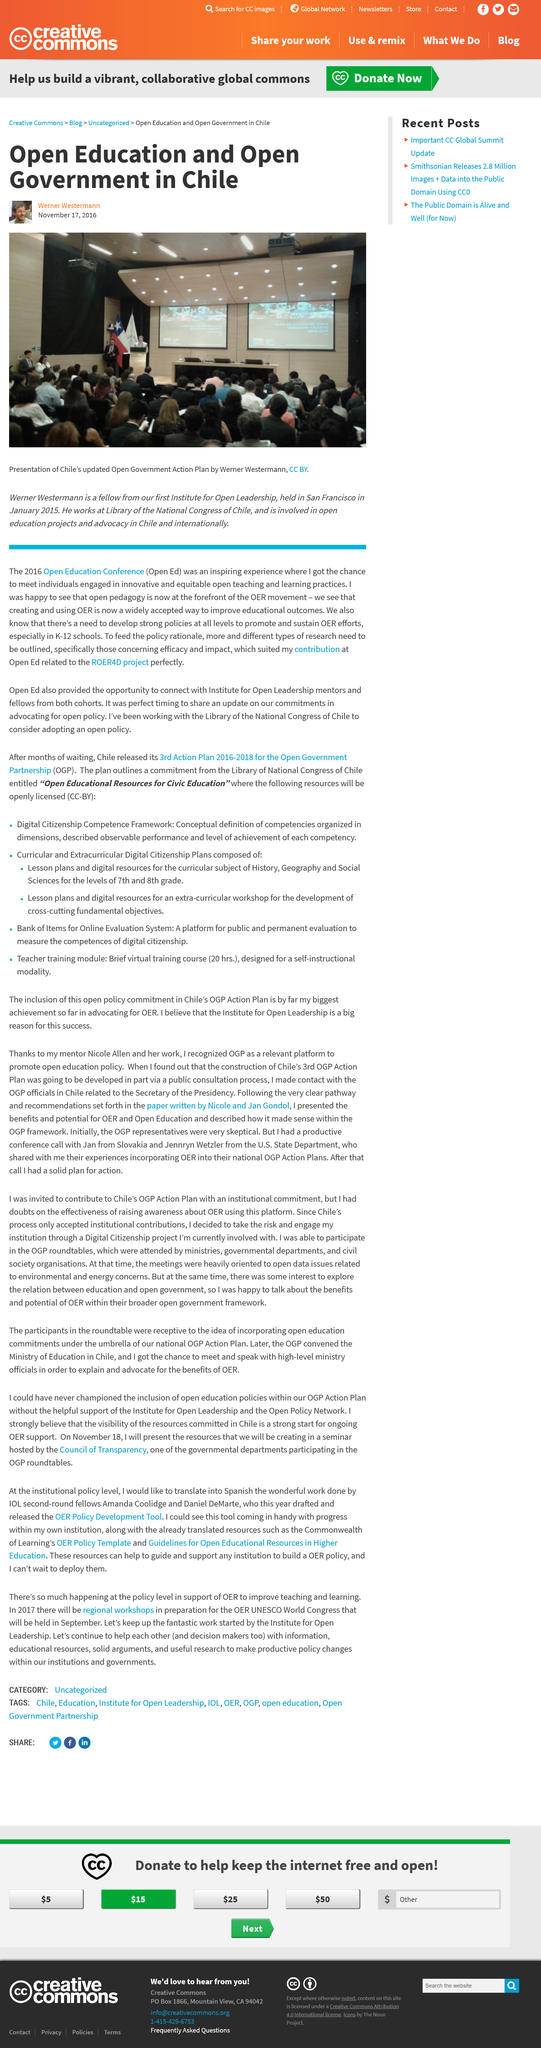Identify some key points in this picture. The first Institute for Open Leadership was held in San Francisco. The author of the article works at the Library of the National Congress of Chile. The first Institute for Open Leadership will be presented by Werner Westermann. 